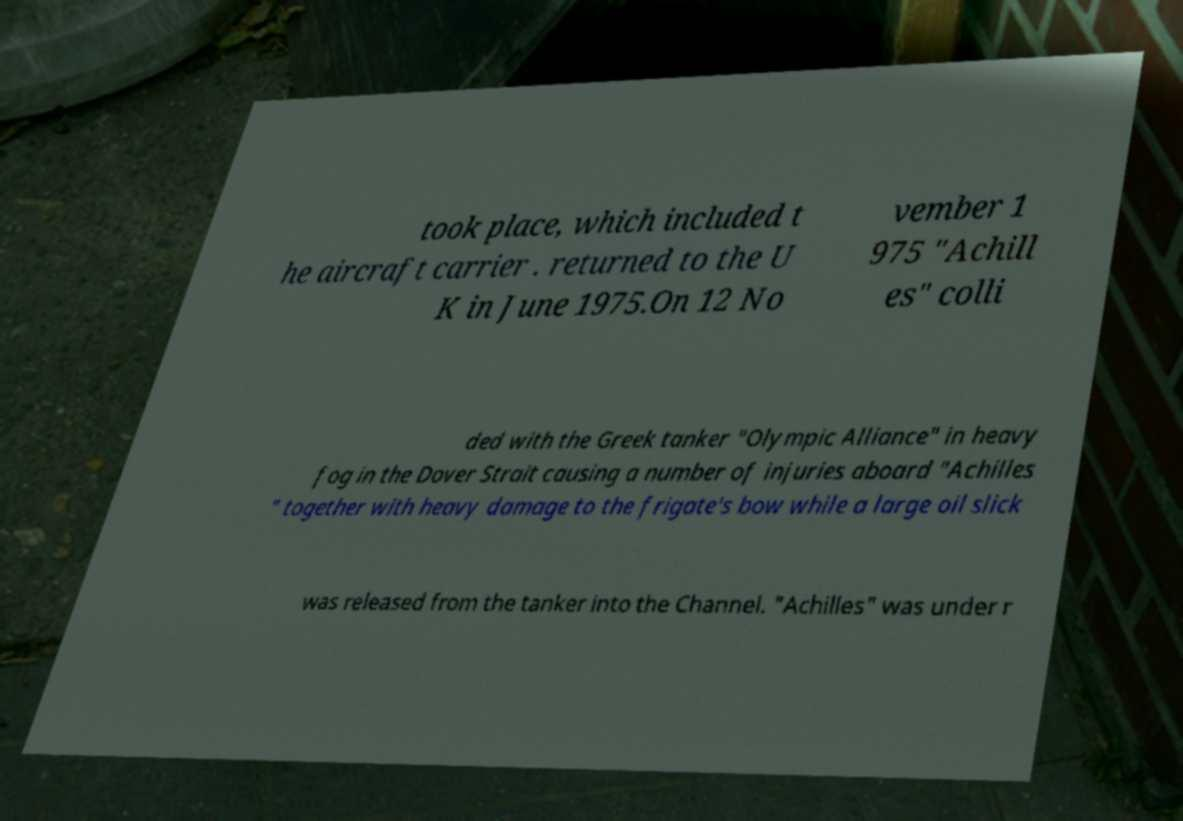For documentation purposes, I need the text within this image transcribed. Could you provide that? took place, which included t he aircraft carrier . returned to the U K in June 1975.On 12 No vember 1 975 "Achill es" colli ded with the Greek tanker "Olympic Alliance" in heavy fog in the Dover Strait causing a number of injuries aboard "Achilles " together with heavy damage to the frigate's bow while a large oil slick was released from the tanker into the Channel. "Achilles" was under r 